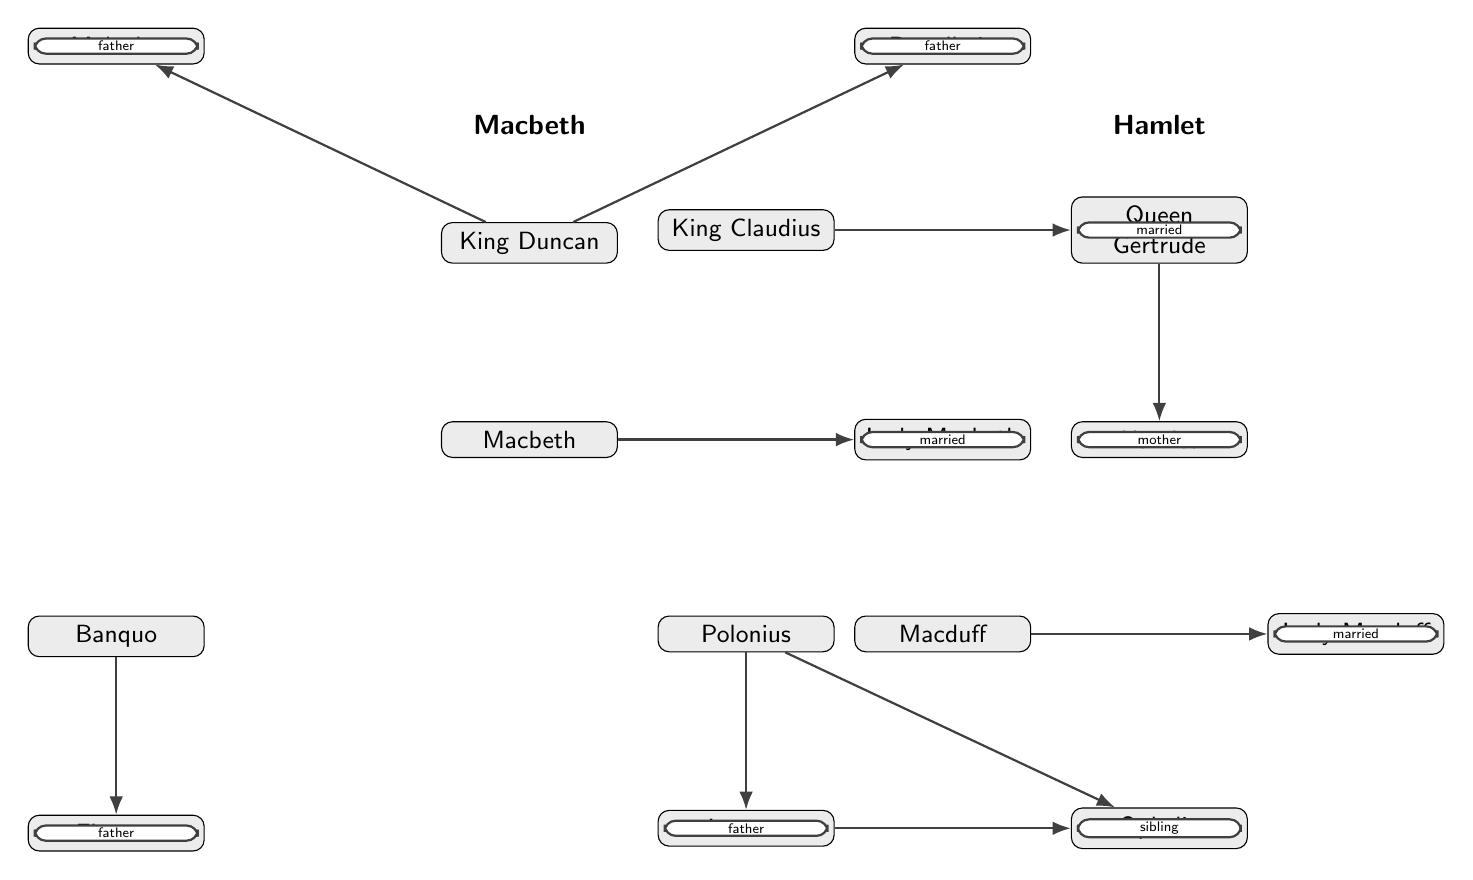What are the two distinct plays represented in the diagram? The diagram represents two plays: 'Macbeth' and 'Hamlet'. This is indicated by the separate groupings at the top of the diagram that define each play.
Answer: Macbeth, Hamlet Who is Lady Macbeth's relationship to Macbeth? The diagram indicates that Lady Macbeth is 'married' to Macbeth, as shown by the edge labeled with this relationship connecting the two nodes.
Answer: married How many characters are connected to Polonius? Polonius has two characters connected to him, Laertes and Ophelia, both shown as children with edges labeled 'father'. This can be counted by observing the edges emerging from the Polonius node.
Answer: 2 What type of relationship do Laertes and Ophelia share? The relationship between Laertes and Ophelia is that of 'sibling', as indicated by the edge connecting them with this designation. This is derived from the diagram's annotations.
Answer: sibling Which character is King Duncan's son? The diagram shows that Malcolm and Donalbain are both connected to King Duncan with edges labeled 'father'. Since both are his sons, Malcolm can be exclusively identified as one of them based on his positioning.
Answer: Malcolm Which character is the mother of Hamlet? The edge connecting Queen Gertrude and Hamlet is labeled 'mother', directly indicating that she is Hamlet's mother. This is derived from the clear relationship label shown in the diagram.
Answer: Queen Gertrude How many total edges are present in the diagram? The diagram shows six edges connecting the various characters through various relationships, such as married and father. Count these connections for the total.
Answer: 6 What role does Macduff's relationship with Lady Macduff signify? The relationship between Macduff and Lady Macduff is indicated as 'married', which implies that they are spouses in the genealogical relationships depicted. This can be seen directly from the labeled edge linking their nodes.
Answer: married Identify the character that is the father of Fleance. The diagram clearly shows Banquo connected to Fleance with an edge labeled 'father', identifying Banquo as Fleance's father based on the diagram's graphical representation.
Answer: Banquo 